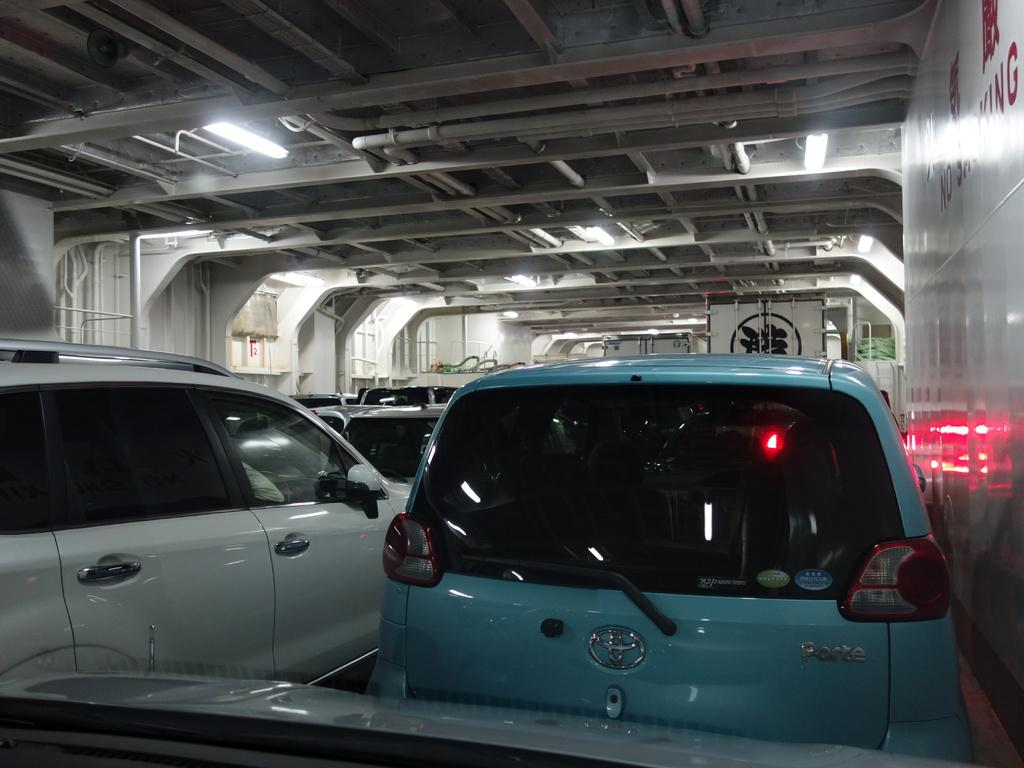What type of vehicles are under the shed in the image? There are cars under the shed in the image. What can be seen illuminated in the image? There are lights visible in the image. What structure is present above the cars in the image? There is a roof in the image. What type of vest is the actor wearing in the image? There is no actor or vest present in the image; it features cars under a shed with lights and a roof. 